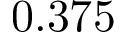<formula> <loc_0><loc_0><loc_500><loc_500>0 . 3 7 5</formula> 